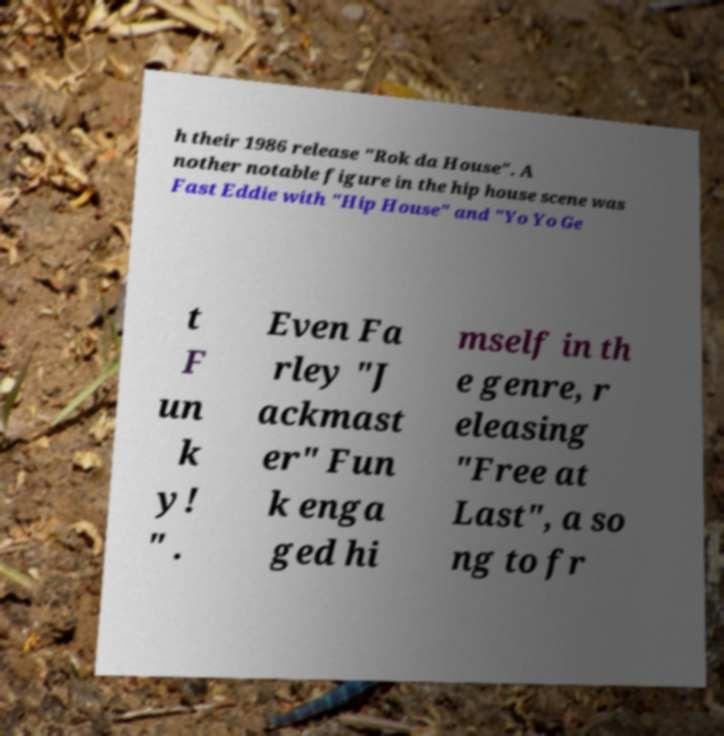For documentation purposes, I need the text within this image transcribed. Could you provide that? h their 1986 release "Rok da House". A nother notable figure in the hip house scene was Fast Eddie with "Hip House" and "Yo Yo Ge t F un k y! " . Even Fa rley "J ackmast er" Fun k enga ged hi mself in th e genre, r eleasing "Free at Last", a so ng to fr 